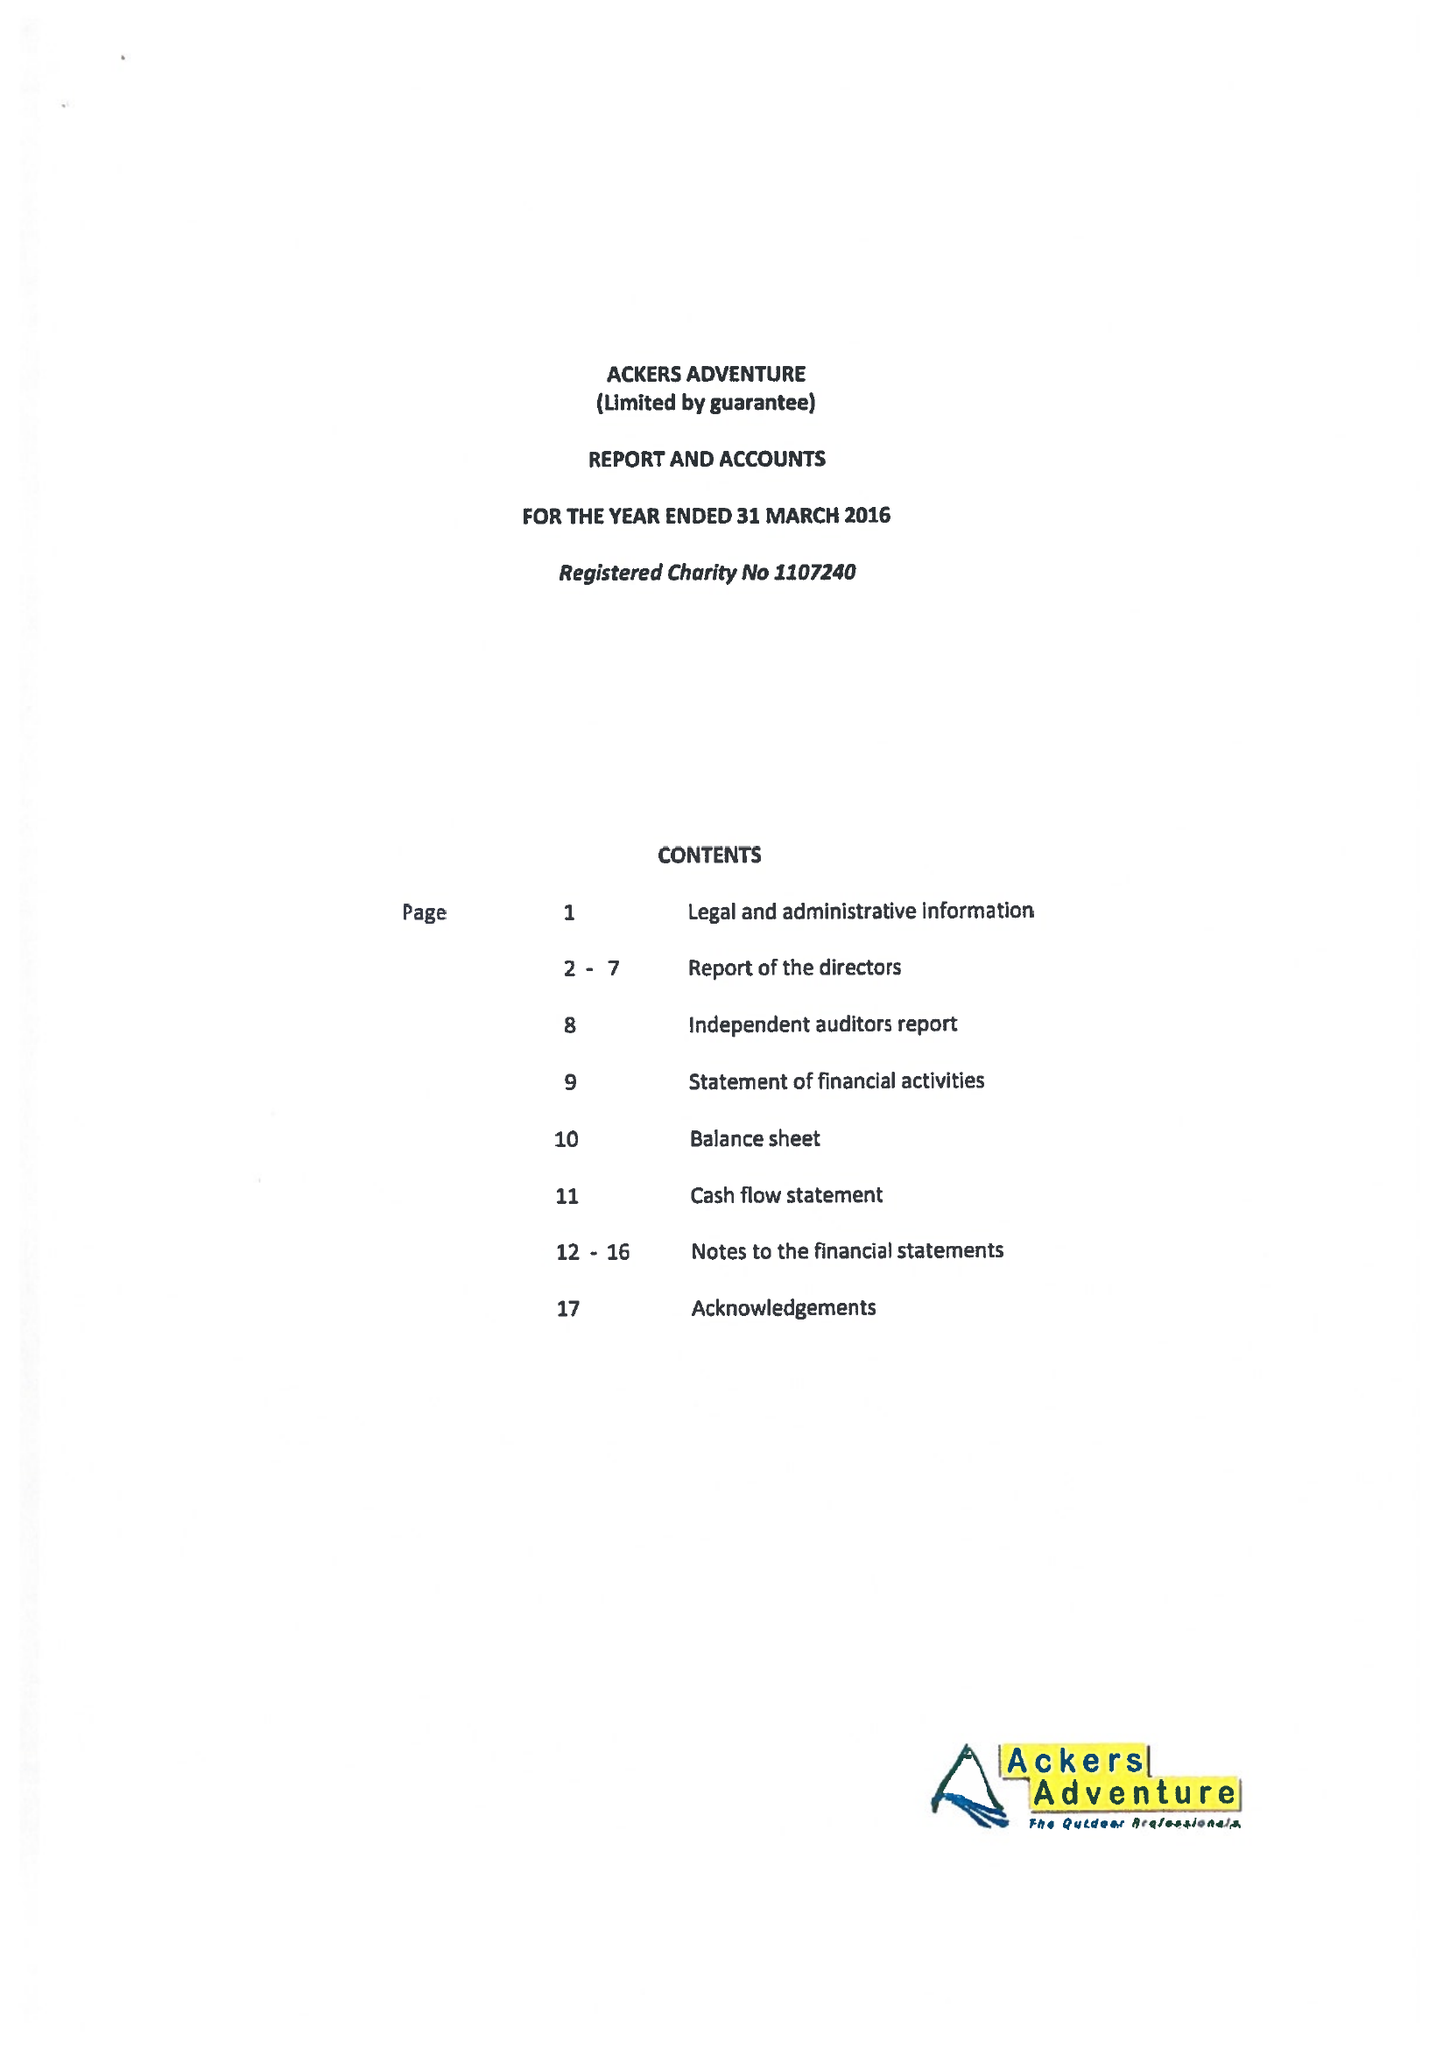What is the value for the charity_number?
Answer the question using a single word or phrase. 1107240 